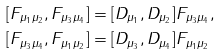Convert formula to latex. <formula><loc_0><loc_0><loc_500><loc_500>[ F _ { \mu _ { 1 } \mu _ { 2 } } , F _ { \mu _ { 3 } \mu _ { 4 } } ] & = [ D _ { \mu _ { 1 } } , D _ { \mu _ { 2 } } ] F _ { \mu _ { 3 } \mu _ { 4 } } , \\ [ F _ { \mu _ { 3 } \mu _ { 4 } } , F _ { \mu _ { 1 } \mu _ { 2 } } ] & = [ D _ { \mu _ { 3 } } , D _ { \mu _ { 4 } } ] F _ { \mu _ { 1 } \mu _ { 2 } }</formula> 